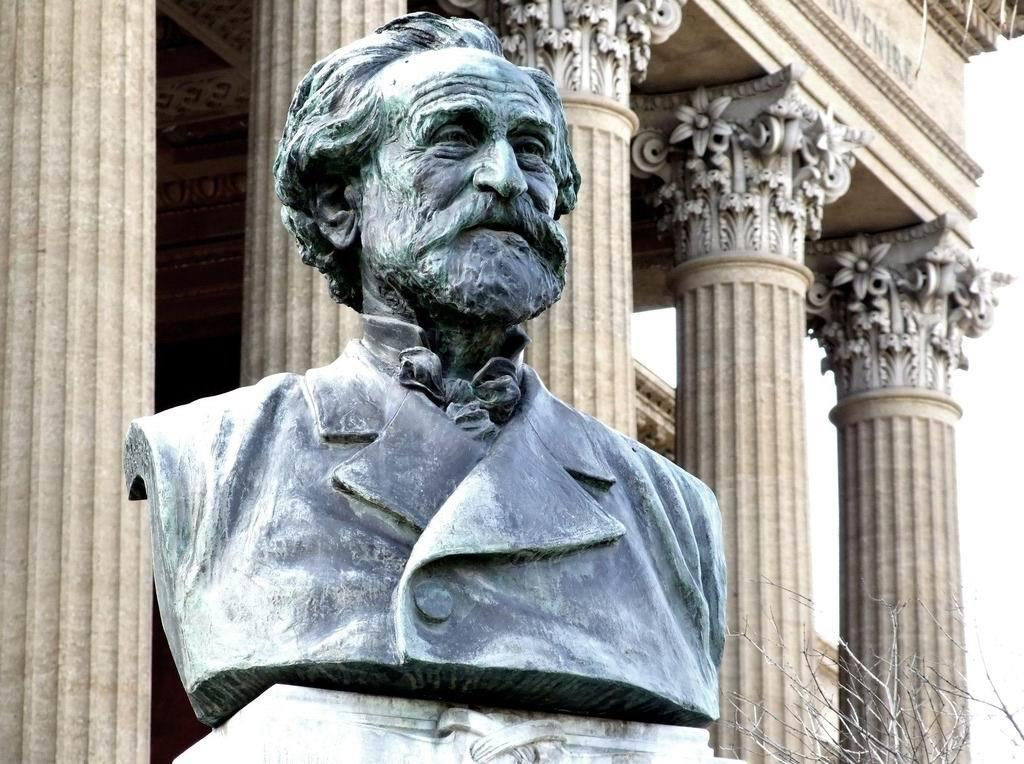What is the main subject of the image? There is a statue of a man in the image. What can be seen in the background of the image? There are pillars in the background of the image. What type of guide is standing next to the statue in the image? There is no guide present in the image; it only features a statue of a man and pillars in the background. 